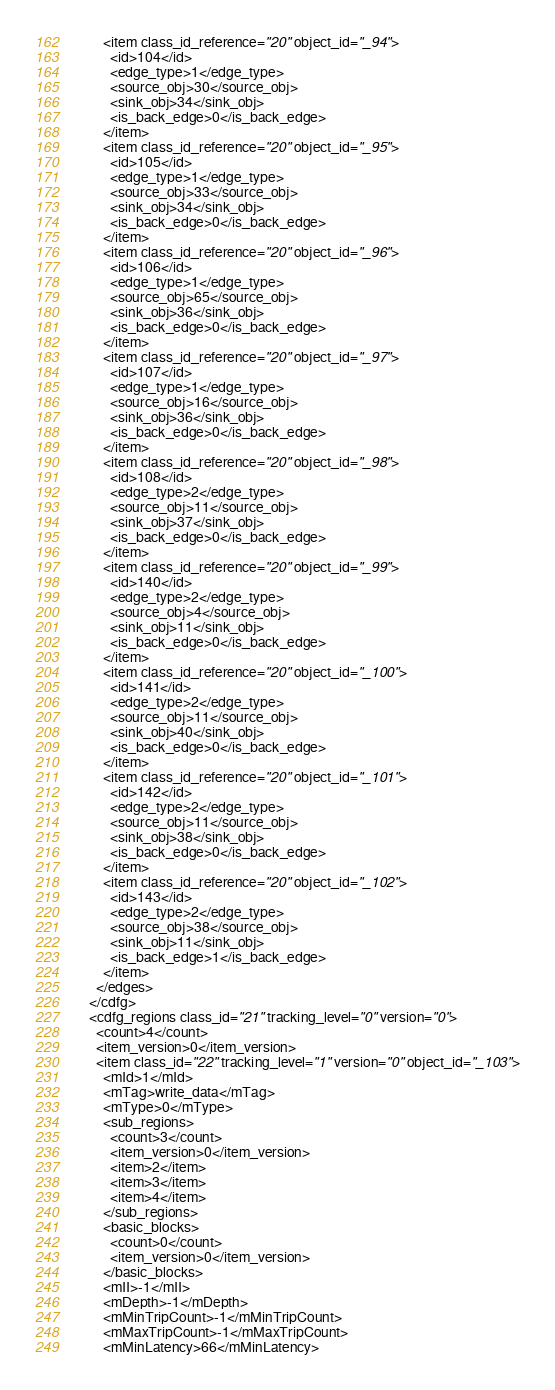Convert code to text. <code><loc_0><loc_0><loc_500><loc_500><_Ada_>        <item class_id_reference="20" object_id="_94">
          <id>104</id>
          <edge_type>1</edge_type>
          <source_obj>30</source_obj>
          <sink_obj>34</sink_obj>
          <is_back_edge>0</is_back_edge>
        </item>
        <item class_id_reference="20" object_id="_95">
          <id>105</id>
          <edge_type>1</edge_type>
          <source_obj>33</source_obj>
          <sink_obj>34</sink_obj>
          <is_back_edge>0</is_back_edge>
        </item>
        <item class_id_reference="20" object_id="_96">
          <id>106</id>
          <edge_type>1</edge_type>
          <source_obj>65</source_obj>
          <sink_obj>36</sink_obj>
          <is_back_edge>0</is_back_edge>
        </item>
        <item class_id_reference="20" object_id="_97">
          <id>107</id>
          <edge_type>1</edge_type>
          <source_obj>16</source_obj>
          <sink_obj>36</sink_obj>
          <is_back_edge>0</is_back_edge>
        </item>
        <item class_id_reference="20" object_id="_98">
          <id>108</id>
          <edge_type>2</edge_type>
          <source_obj>11</source_obj>
          <sink_obj>37</sink_obj>
          <is_back_edge>0</is_back_edge>
        </item>
        <item class_id_reference="20" object_id="_99">
          <id>140</id>
          <edge_type>2</edge_type>
          <source_obj>4</source_obj>
          <sink_obj>11</sink_obj>
          <is_back_edge>0</is_back_edge>
        </item>
        <item class_id_reference="20" object_id="_100">
          <id>141</id>
          <edge_type>2</edge_type>
          <source_obj>11</source_obj>
          <sink_obj>40</sink_obj>
          <is_back_edge>0</is_back_edge>
        </item>
        <item class_id_reference="20" object_id="_101">
          <id>142</id>
          <edge_type>2</edge_type>
          <source_obj>11</source_obj>
          <sink_obj>38</sink_obj>
          <is_back_edge>0</is_back_edge>
        </item>
        <item class_id_reference="20" object_id="_102">
          <id>143</id>
          <edge_type>2</edge_type>
          <source_obj>38</source_obj>
          <sink_obj>11</sink_obj>
          <is_back_edge>1</is_back_edge>
        </item>
      </edges>
    </cdfg>
    <cdfg_regions class_id="21" tracking_level="0" version="0">
      <count>4</count>
      <item_version>0</item_version>
      <item class_id="22" tracking_level="1" version="0" object_id="_103">
        <mId>1</mId>
        <mTag>write_data</mTag>
        <mType>0</mType>
        <sub_regions>
          <count>3</count>
          <item_version>0</item_version>
          <item>2</item>
          <item>3</item>
          <item>4</item>
        </sub_regions>
        <basic_blocks>
          <count>0</count>
          <item_version>0</item_version>
        </basic_blocks>
        <mII>-1</mII>
        <mDepth>-1</mDepth>
        <mMinTripCount>-1</mMinTripCount>
        <mMaxTripCount>-1</mMaxTripCount>
        <mMinLatency>66</mMinLatency></code> 